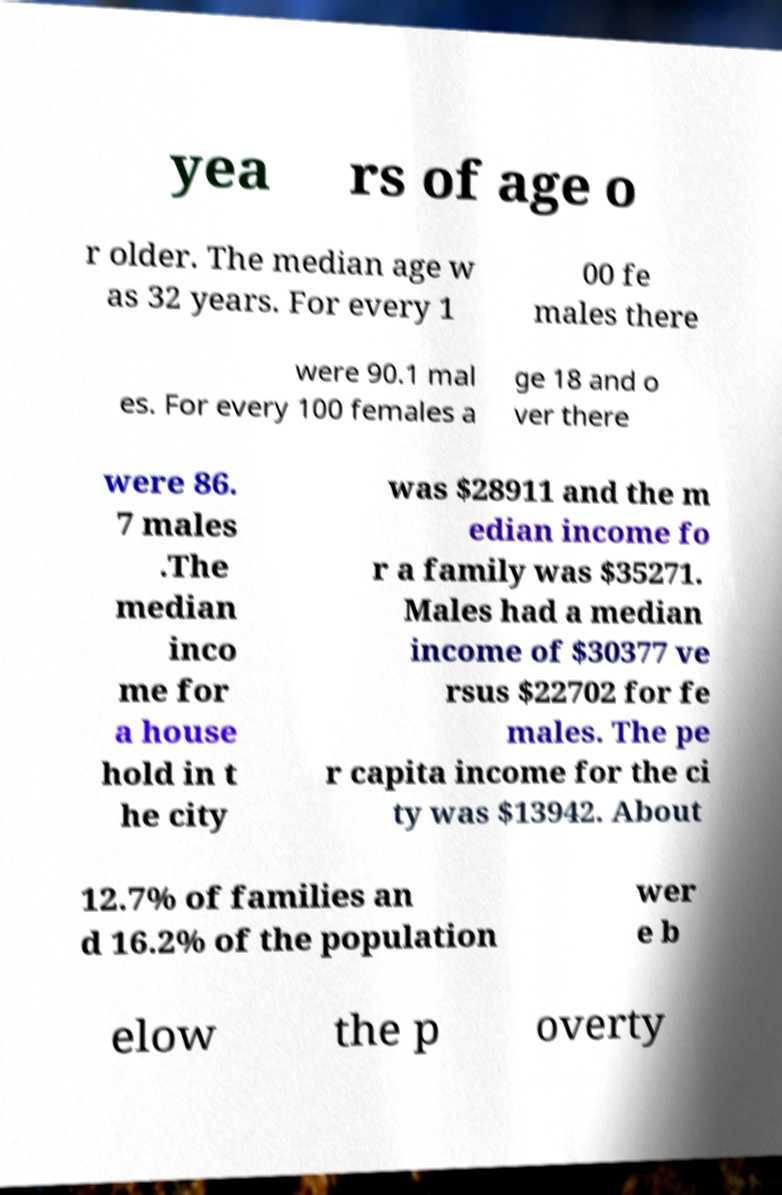Can you read and provide the text displayed in the image?This photo seems to have some interesting text. Can you extract and type it out for me? yea rs of age o r older. The median age w as 32 years. For every 1 00 fe males there were 90.1 mal es. For every 100 females a ge 18 and o ver there were 86. 7 males .The median inco me for a house hold in t he city was $28911 and the m edian income fo r a family was $35271. Males had a median income of $30377 ve rsus $22702 for fe males. The pe r capita income for the ci ty was $13942. About 12.7% of families an d 16.2% of the population wer e b elow the p overty 